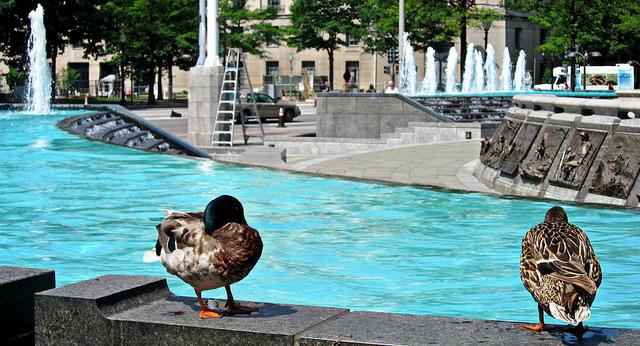How many ducks are here?
Quick response, please. 2. Is this located in the town square?
Keep it brief. Yes. Are they both mallard ducks?
Concise answer only. Yes. What color is the ducks neck?
Answer briefly. Black. 